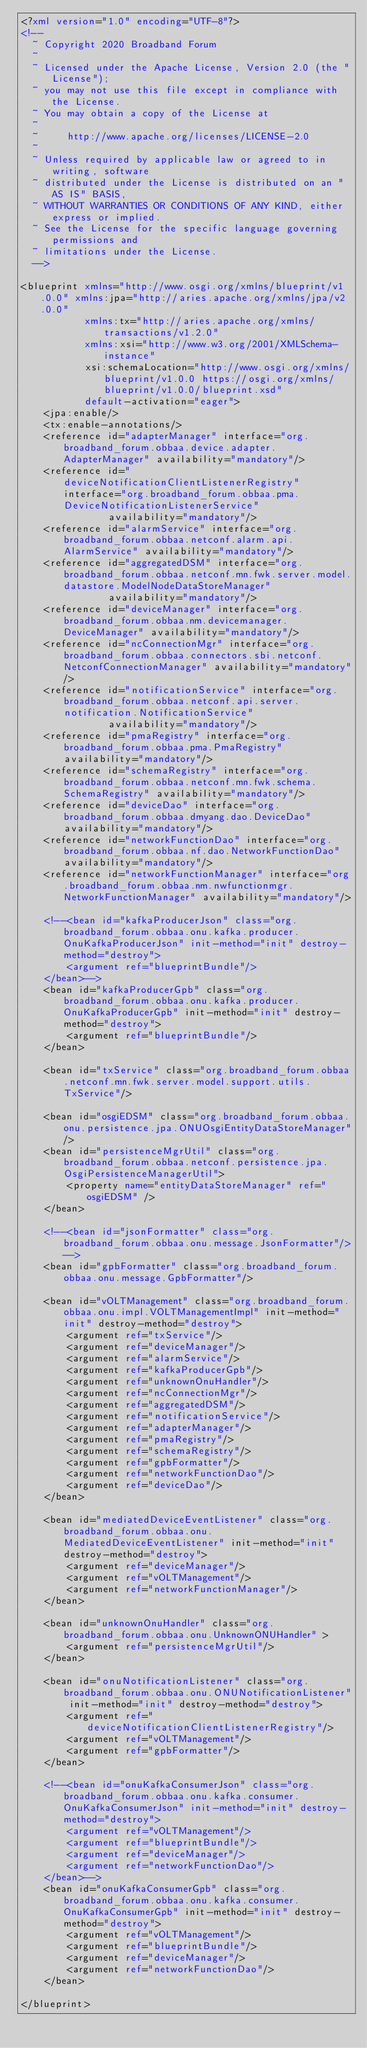<code> <loc_0><loc_0><loc_500><loc_500><_XML_><?xml version="1.0" encoding="UTF-8"?>
<!--
  ~ Copyright 2020 Broadband Forum
  ~
  ~ Licensed under the Apache License, Version 2.0 (the "License");
  ~ you may not use this file except in compliance with the License.
  ~ You may obtain a copy of the License at
  ~
  ~     http://www.apache.org/licenses/LICENSE-2.0
  ~
  ~ Unless required by applicable law or agreed to in writing, software
  ~ distributed under the License is distributed on an "AS IS" BASIS,
  ~ WITHOUT WARRANTIES OR CONDITIONS OF ANY KIND, either express or implied.
  ~ See the License for the specific language governing permissions and
  ~ limitations under the License.
  -->

<blueprint xmlns="http://www.osgi.org/xmlns/blueprint/v1.0.0" xmlns:jpa="http://aries.apache.org/xmlns/jpa/v2.0.0"
           xmlns:tx="http://aries.apache.org/xmlns/transactions/v1.2.0"
           xmlns:xsi="http://www.w3.org/2001/XMLSchema-instance"
           xsi:schemaLocation="http://www.osgi.org/xmlns/blueprint/v1.0.0 https://osgi.org/xmlns/blueprint/v1.0.0/blueprint.xsd"
           default-activation="eager">
    <jpa:enable/>
    <tx:enable-annotations/>
    <reference id="adapterManager" interface="org.broadband_forum.obbaa.device.adapter.AdapterManager" availability="mandatory"/>
    <reference id="deviceNotificationClientListenerRegistry" interface="org.broadband_forum.obbaa.pma.DeviceNotificationListenerService"
               availability="mandatory"/>
    <reference id="alarmService" interface="org.broadband_forum.obbaa.netconf.alarm.api.AlarmService" availability="mandatory"/>
    <reference id="aggregatedDSM" interface="org.broadband_forum.obbaa.netconf.mn.fwk.server.model.datastore.ModelNodeDataStoreManager"
               availability="mandatory"/>
    <reference id="deviceManager" interface="org.broadband_forum.obbaa.nm.devicemanager.DeviceManager" availability="mandatory"/>
    <reference id="ncConnectionMgr" interface="org.broadband_forum.obbaa.connectors.sbi.netconf.NetconfConnectionManager" availability="mandatory"/>
    <reference id="notificationService" interface="org.broadband_forum.obbaa.netconf.api.server.notification.NotificationService"
               availability="mandatory"/>
    <reference id="pmaRegistry" interface="org.broadband_forum.obbaa.pma.PmaRegistry" availability="mandatory"/>
    <reference id="schemaRegistry" interface="org.broadband_forum.obbaa.netconf.mn.fwk.schema.SchemaRegistry" availability="mandatory"/>
    <reference id="deviceDao" interface="org.broadband_forum.obbaa.dmyang.dao.DeviceDao" availability="mandatory"/>
    <reference id="networkFunctionDao" interface="org.broadband_forum.obbaa.nf.dao.NetworkFunctionDao" availability="mandatory"/>
    <reference id="networkFunctionManager" interface="org.broadband_forum.obbaa.nm.nwfunctionmgr.NetworkFunctionManager" availability="mandatory"/>

    <!--<bean id="kafkaProducerJson" class="org.broadband_forum.obbaa.onu.kafka.producer.OnuKafkaProducerJson" init-method="init" destroy-method="destroy">
        <argument ref="blueprintBundle"/>
    </bean>-->
    <bean id="kafkaProducerGpb" class="org.broadband_forum.obbaa.onu.kafka.producer.OnuKafkaProducerGpb" init-method="init" destroy-method="destroy">
        <argument ref="blueprintBundle"/>
    </bean>

    <bean id="txService" class="org.broadband_forum.obbaa.netconf.mn.fwk.server.model.support.utils.TxService"/>

    <bean id="osgiEDSM" class="org.broadband_forum.obbaa.onu.persistence.jpa.ONUOsgiEntityDataStoreManager"/>
    <bean id="persistenceMgrUtil" class="org.broadband_forum.obbaa.netconf.persistence.jpa.OsgiPersistenceManagerUtil">
        <property name="entityDataStoreManager" ref="osgiEDSM" />
    </bean>

    <!--<bean id="jsonFormatter" class="org.broadband_forum.obbaa.onu.message.JsonFormatter"/>-->
    <bean id="gpbFormatter" class="org.broadband_forum.obbaa.onu.message.GpbFormatter"/>

    <bean id="vOLTManagement" class="org.broadband_forum.obbaa.onu.impl.VOLTManagementImpl" init-method="init" destroy-method="destroy">
        <argument ref="txService"/>
        <argument ref="deviceManager"/>
        <argument ref="alarmService"/>
        <argument ref="kafkaProducerGpb"/>
        <argument ref="unknownOnuHandler"/>
        <argument ref="ncConnectionMgr"/>
        <argument ref="aggregatedDSM"/>
        <argument ref="notificationService"/>
        <argument ref="adapterManager"/>
        <argument ref="pmaRegistry"/>
        <argument ref="schemaRegistry"/>
        <argument ref="gpbFormatter"/>
        <argument ref="networkFunctionDao"/>
        <argument ref="deviceDao"/>
    </bean>

    <bean id="mediatedDeviceEventListener" class="org.broadband_forum.obbaa.onu.MediatedDeviceEventListener" init-method="init" destroy-method="destroy">
        <argument ref="deviceManager"/>
        <argument ref="vOLTManagement"/>
        <argument ref="networkFunctionManager"/>
    </bean>

    <bean id="unknownOnuHandler" class="org.broadband_forum.obbaa.onu.UnknownONUHandler" >
        <argument ref="persistenceMgrUtil"/>
    </bean>

    <bean id="onuNotificationListener" class="org.broadband_forum.obbaa.onu.ONUNotificationListener" init-method="init" destroy-method="destroy">
        <argument ref="deviceNotificationClientListenerRegistry"/>
        <argument ref="vOLTManagement"/>
        <argument ref="gpbFormatter"/>
    </bean>

    <!--<bean id="onuKafkaConsumerJson" class="org.broadband_forum.obbaa.onu.kafka.consumer.OnuKafkaConsumerJson" init-method="init" destroy-method="destroy">
        <argument ref="vOLTManagement"/>
        <argument ref="blueprintBundle"/>
        <argument ref="deviceManager"/>
        <argument ref="networkFunctionDao"/>
    </bean>-->
    <bean id="onuKafkaConsumerGpb" class="org.broadband_forum.obbaa.onu.kafka.consumer.OnuKafkaConsumerGpb" init-method="init" destroy-method="destroy">
        <argument ref="vOLTManagement"/>
        <argument ref="blueprintBundle"/>
        <argument ref="deviceManager"/>
        <argument ref="networkFunctionDao"/>
    </bean>

</blueprint></code> 